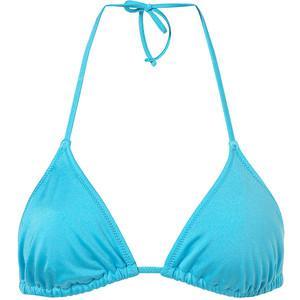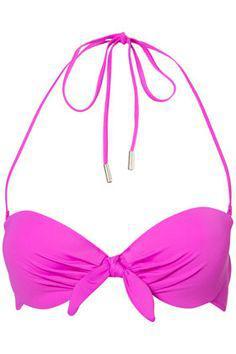The first image is the image on the left, the second image is the image on the right. Given the left and right images, does the statement "The images show only brightly colored bikini tops that tie halter-style." hold true? Answer yes or no. Yes. 